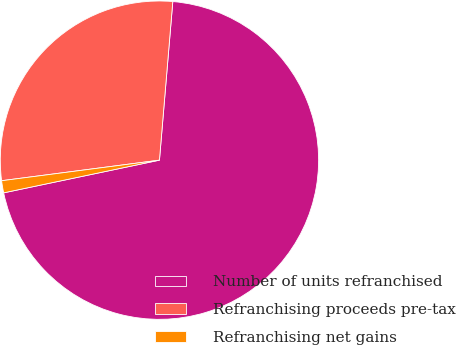Convert chart to OTSL. <chart><loc_0><loc_0><loc_500><loc_500><pie_chart><fcel>Number of units refranchised<fcel>Refranchising proceeds pre-tax<fcel>Refranchising net gains<nl><fcel>70.37%<fcel>28.4%<fcel>1.23%<nl></chart> 